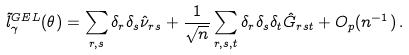<formula> <loc_0><loc_0><loc_500><loc_500>\tilde { l } ^ { G E L } _ { \gamma } ( \theta ) = \sum _ { r , s } \delta _ { r } \delta _ { s } \hat { \nu } _ { r s } + \frac { 1 } { \sqrt { n } } \sum _ { r , s , t } \delta _ { r } \delta _ { s } \delta _ { t } \hat { G } _ { r s t } + O _ { p } ( n ^ { - 1 } ) \, .</formula> 